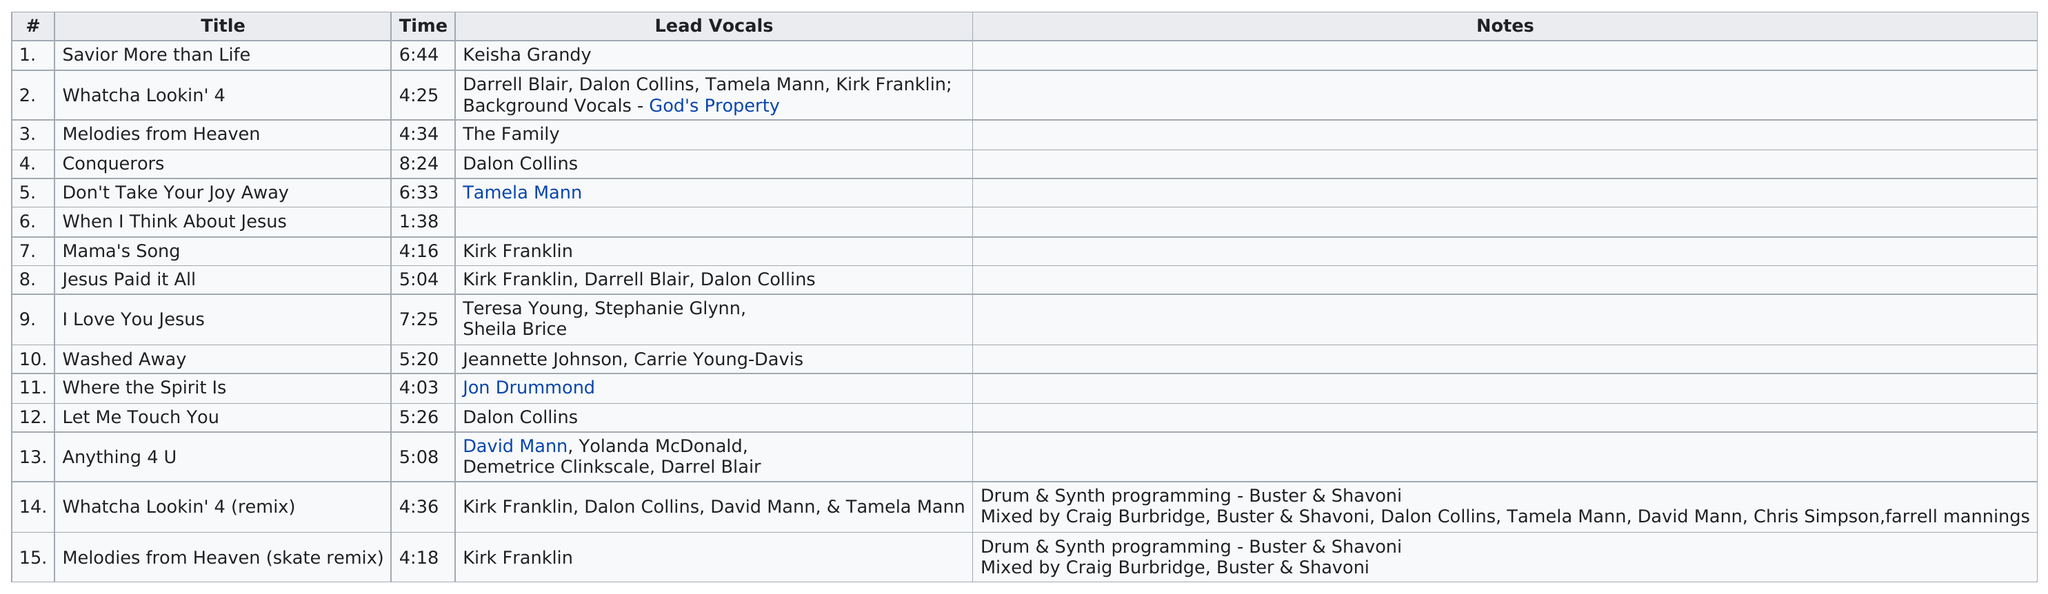Indicate a few pertinent items in this graphic. The lead vocals are listed for every song, except for when I Think About Jesus, where there is a guitar solo instead. The song that features the same individuals performing drum and synth programming as the "Whatcha Lookin' 4 (remix)" from the album "Melodies from Heaven?" is "Whatcha Lookin' 4 (remix)". The track entitled 'What You Lookin' 4 Lasts for Only 1:38? When I Think About Jesus...' lasts for only 1:38. There were 1 track that did not contain any lead vocals. The album has 15 tracks. 